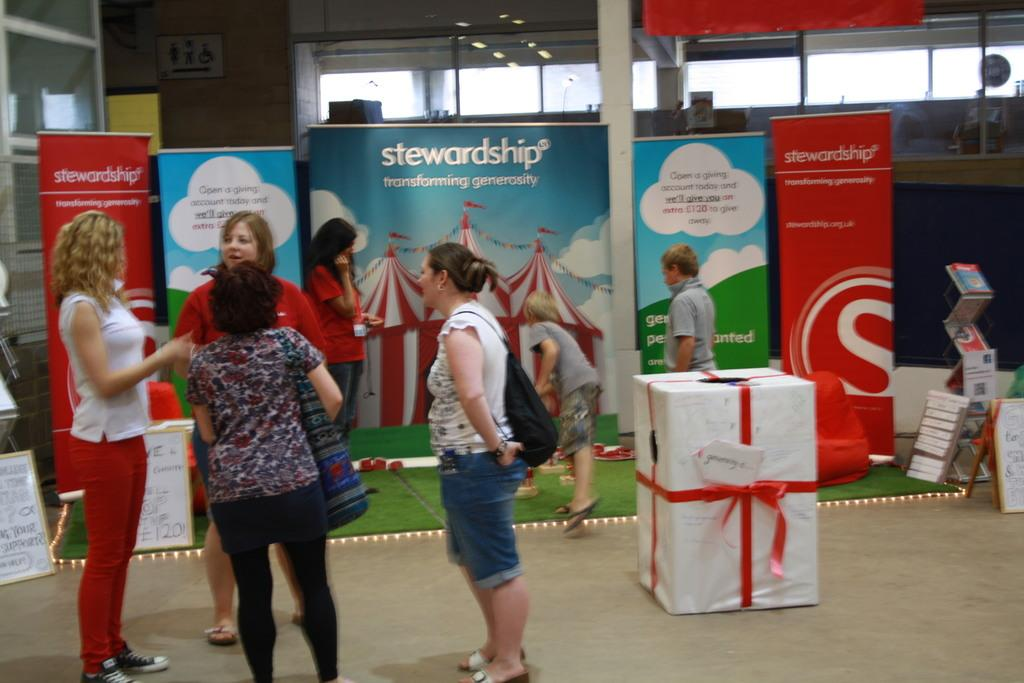Provide a one-sentence caption for the provided image. Four women are chatting in-front of a booth that reads "stewardship". 